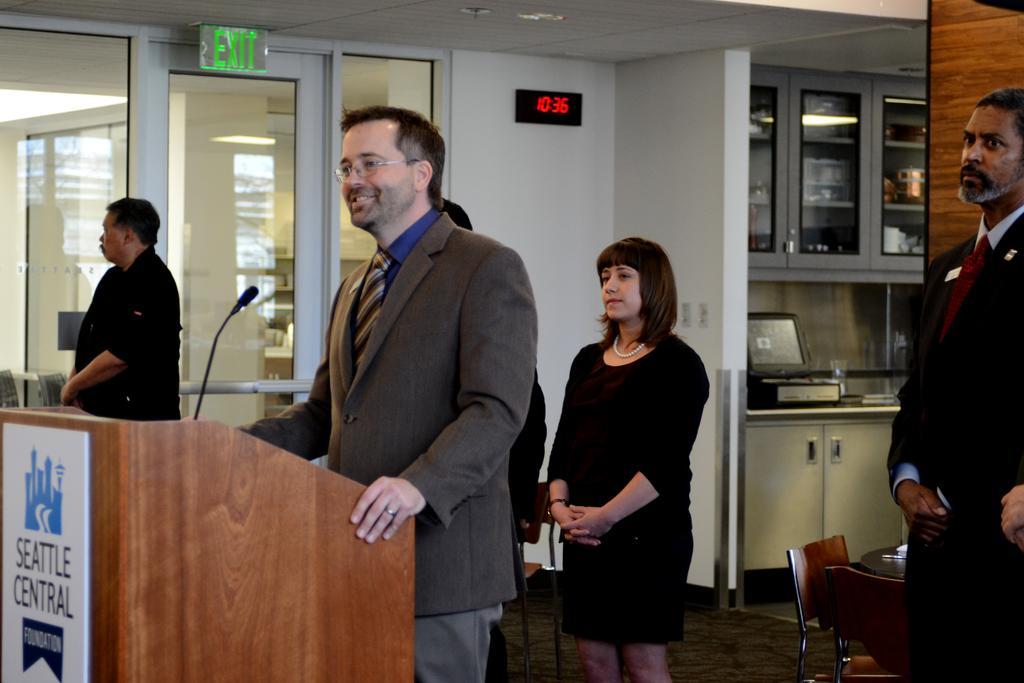Describe this image in one or two sentences. This image consists of a man wearing suit is standing near the podium and talking. In the background, there are many people standing are wearing black dress. In the middle, there is a kitchen. At the bottom, there is floor. To the left, there is a door. 